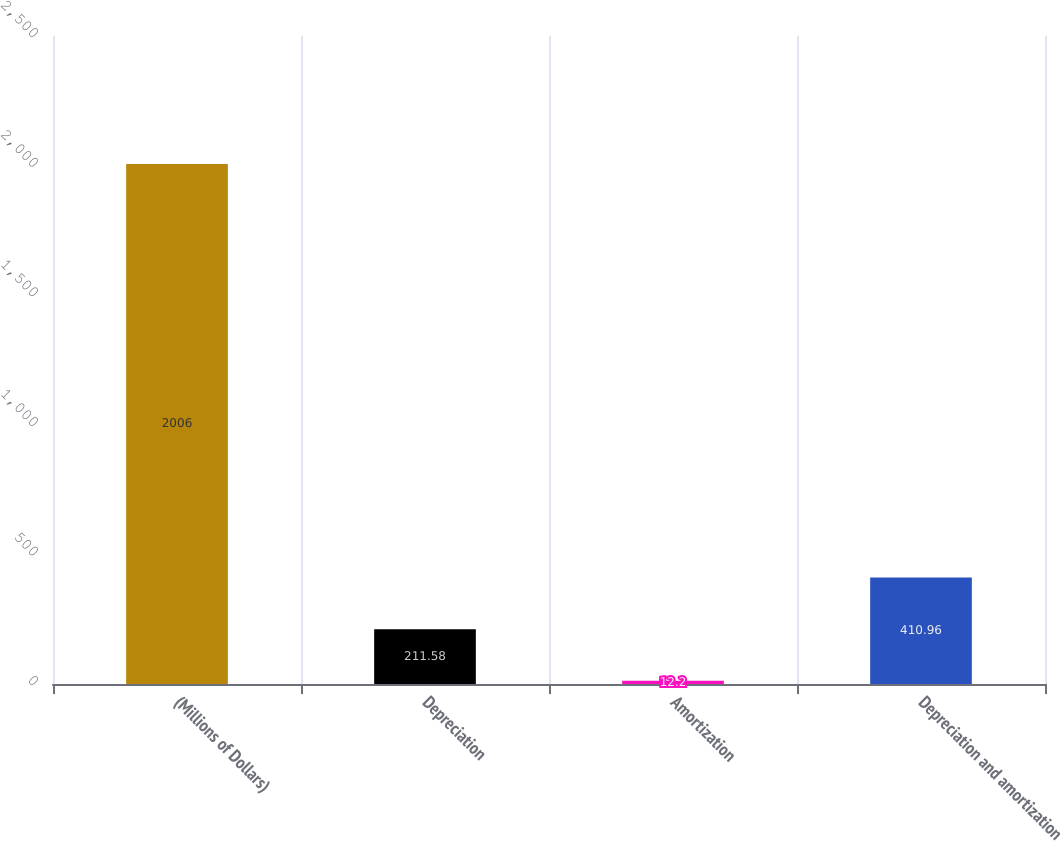Convert chart to OTSL. <chart><loc_0><loc_0><loc_500><loc_500><bar_chart><fcel>(Millions of Dollars)<fcel>Depreciation<fcel>Amortization<fcel>Depreciation and amortization<nl><fcel>2006<fcel>211.58<fcel>12.2<fcel>410.96<nl></chart> 